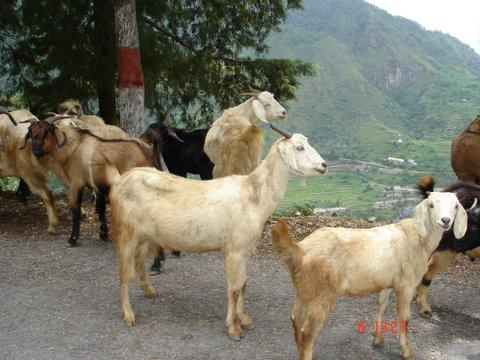Question: what is in the background?
Choices:
A. Office buildings.
B. Factories.
C. Mountains.
D. Hotels.
Answer with the letter. Answer: C Question: what color is on the tree?
Choices:
A. Brown.
B. Pink.
C. Red.
D. Blue.
Answer with the letter. Answer: C 